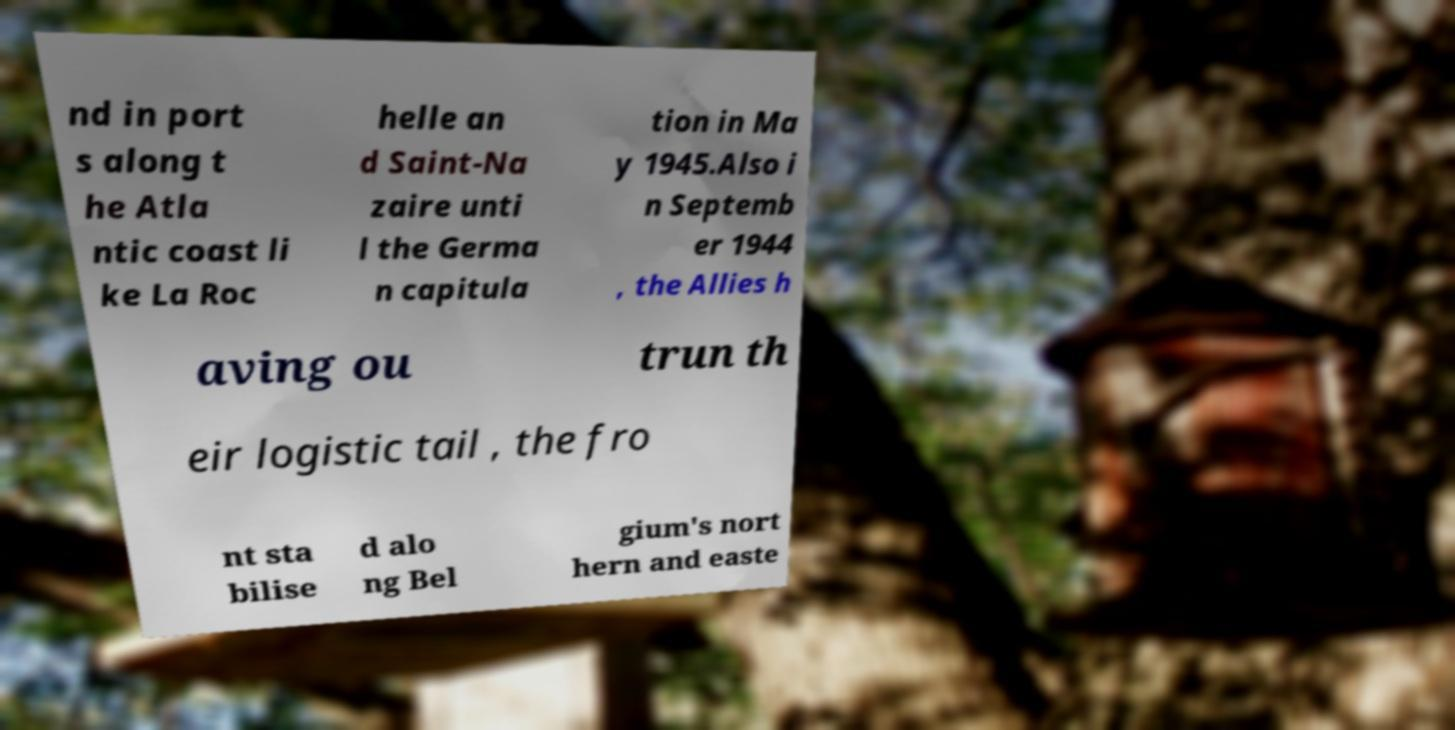There's text embedded in this image that I need extracted. Can you transcribe it verbatim? nd in port s along t he Atla ntic coast li ke La Roc helle an d Saint-Na zaire unti l the Germa n capitula tion in Ma y 1945.Also i n Septemb er 1944 , the Allies h aving ou trun th eir logistic tail , the fro nt sta bilise d alo ng Bel gium's nort hern and easte 